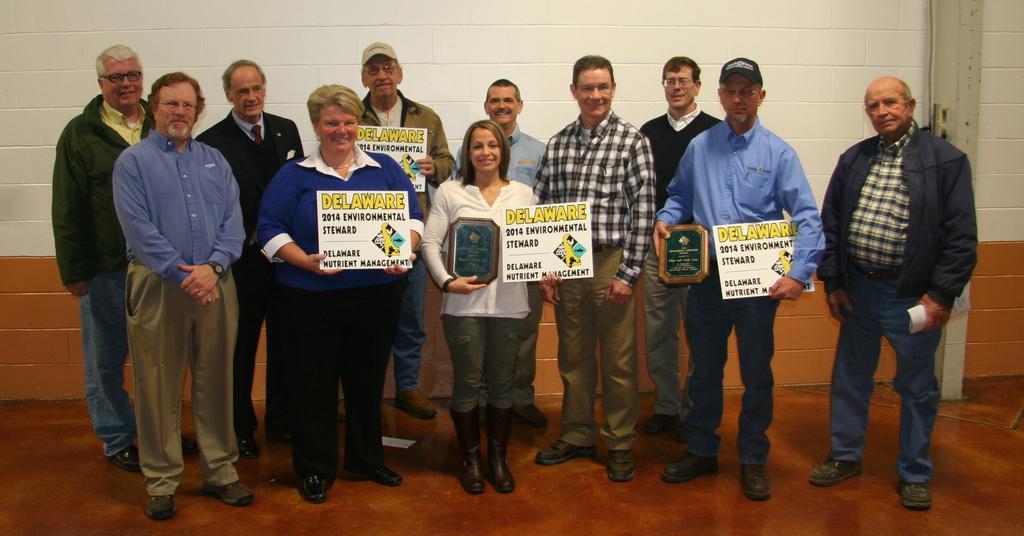Please provide a concise description of this image. In the center of the picture there are many people standing, holding placards and memorandum. In background it is well. 